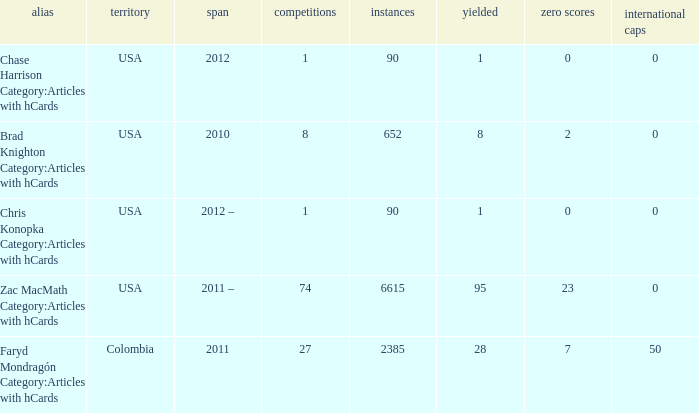When 2010 is the year what is the game? 8.0. 